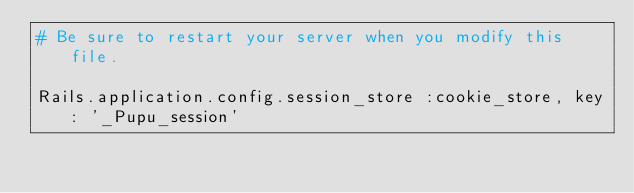Convert code to text. <code><loc_0><loc_0><loc_500><loc_500><_Ruby_># Be sure to restart your server when you modify this file.

Rails.application.config.session_store :cookie_store, key: '_Pupu_session'
</code> 